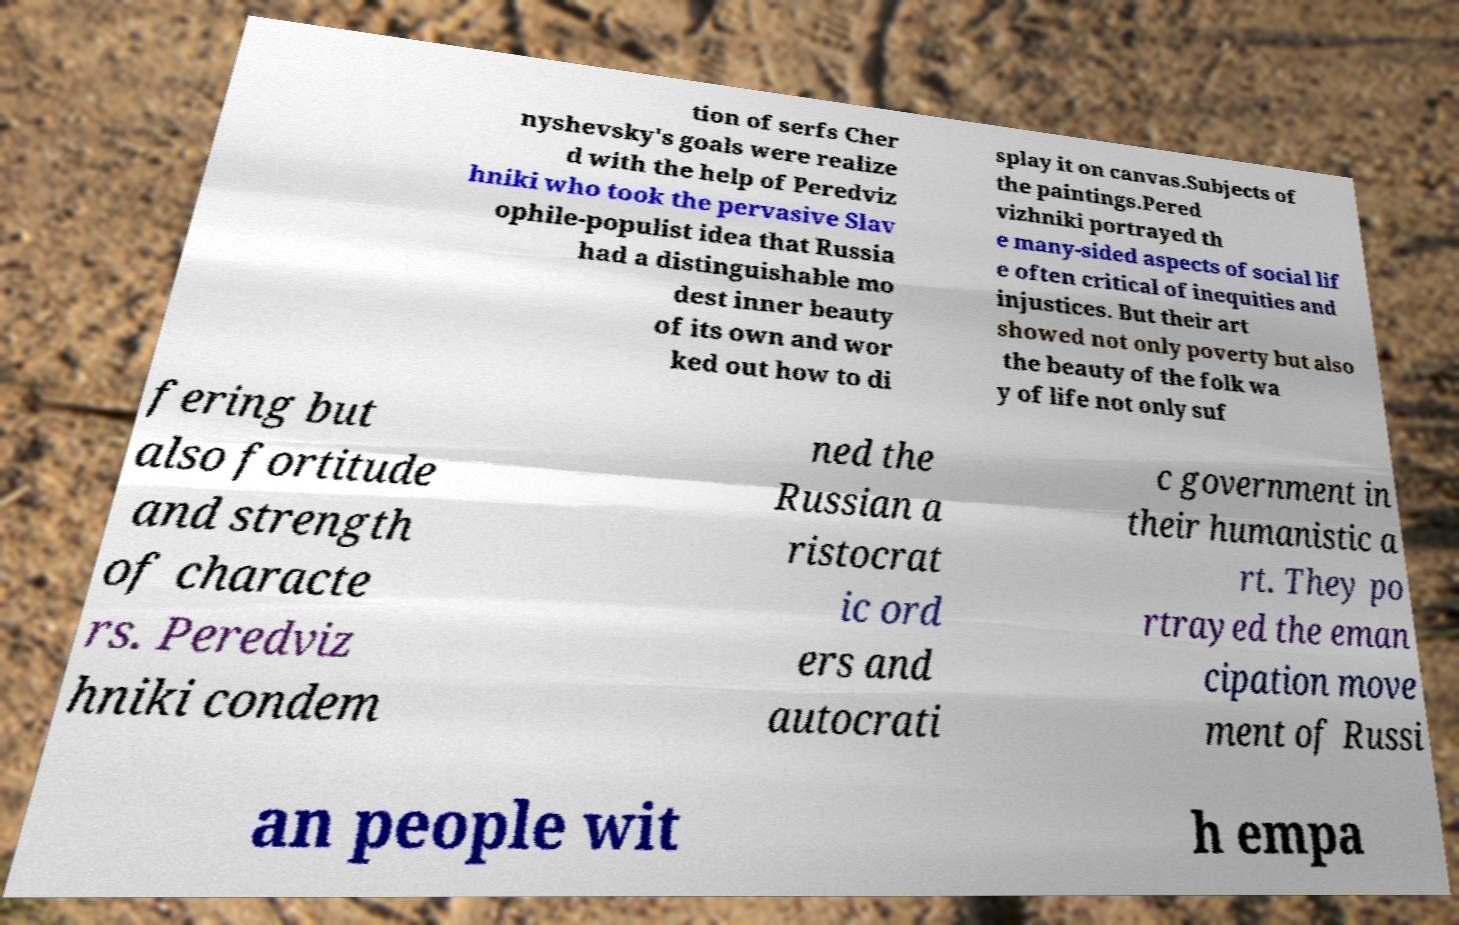What messages or text are displayed in this image? I need them in a readable, typed format. tion of serfs Cher nyshevsky's goals were realize d with the help of Peredviz hniki who took the pervasive Slav ophile-populist idea that Russia had a distinguishable mo dest inner beauty of its own and wor ked out how to di splay it on canvas.Subjects of the paintings.Pered vizhniki portrayed th e many-sided aspects of social lif e often critical of inequities and injustices. But their art showed not only poverty but also the beauty of the folk wa y of life not only suf fering but also fortitude and strength of characte rs. Peredviz hniki condem ned the Russian a ristocrat ic ord ers and autocrati c government in their humanistic a rt. They po rtrayed the eman cipation move ment of Russi an people wit h empa 